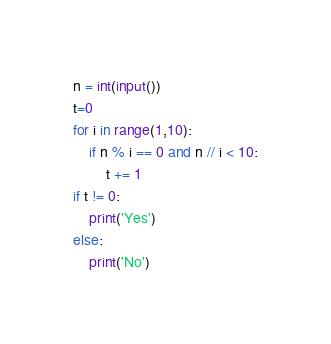Convert code to text. <code><loc_0><loc_0><loc_500><loc_500><_Python_>n = int(input())
t=0
for i in range(1,10):
    if n % i == 0 and n // i < 10:
        t += 1
if t != 0:
    print('Yes')
else:
    print('No')
</code> 